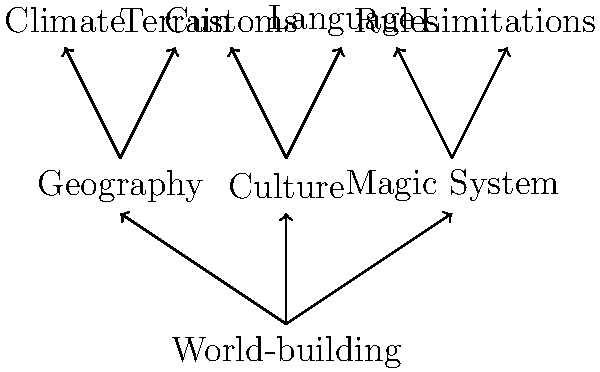In the context of fantasy literature world-building, which element is most directly connected to the development of a unique "Language" within the created universe, according to the mind map? To answer this question, we need to analyze the structure of the mind map:

1. The central node is "World-building," which branches out into three main categories.
2. These categories are "Geography," "Culture," and "Magic System."
3. Each of these main categories has two sub-elements:
   - Geography: Climate and Terrain
   - Culture: Customs and Language
   - Magic System: Rules and Limitations
4. We can see that "Language" is directly connected to "Culture."
5. This connection implies that in fantasy world-building, the development of a unique language is most closely associated with the cultural aspects of the created world.
6. The placement of "Language" under "Culture" suggests that it is an integral part of the cultural identity within the fantasy universe.
7. This association reflects the real-world relationship between language and culture, where language often shapes and is shaped by cultural practices and beliefs.

Therefore, based on the mind map, the element most directly connected to the development of a unique "Language" in fantasy world-building is "Culture."
Answer: Culture 